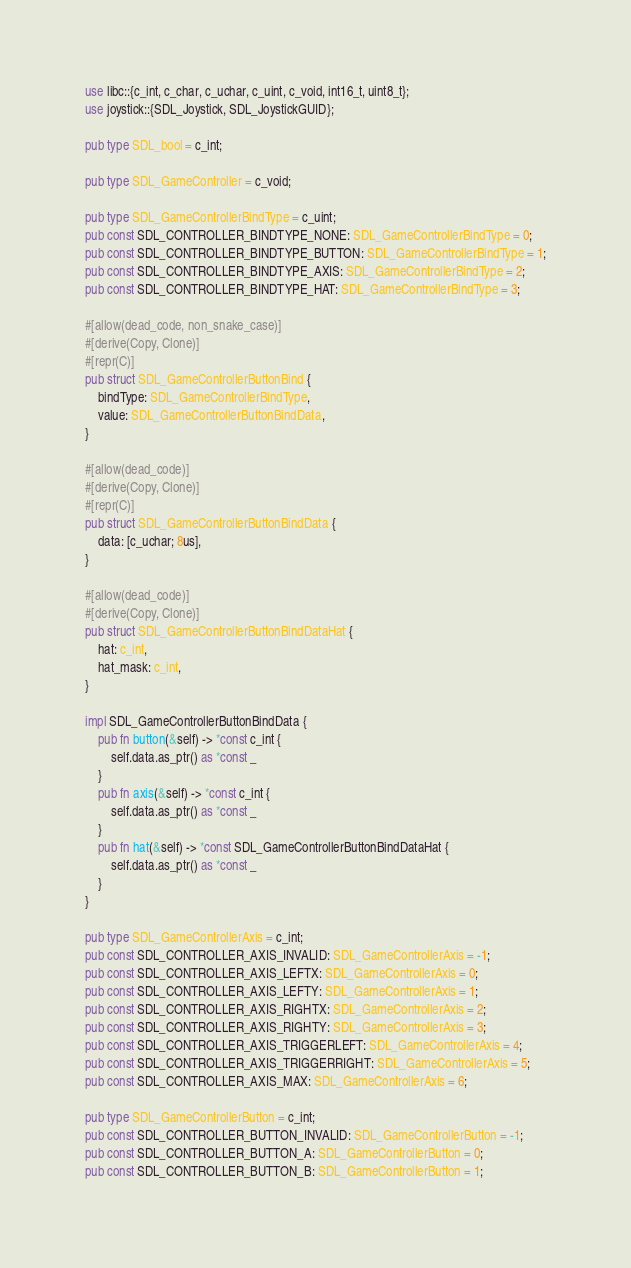Convert code to text. <code><loc_0><loc_0><loc_500><loc_500><_Rust_>use libc::{c_int, c_char, c_uchar, c_uint, c_void, int16_t, uint8_t};
use joystick::{SDL_Joystick, SDL_JoystickGUID};

pub type SDL_bool = c_int;

pub type SDL_GameController = c_void;

pub type SDL_GameControllerBindType = c_uint;
pub const SDL_CONTROLLER_BINDTYPE_NONE: SDL_GameControllerBindType = 0;
pub const SDL_CONTROLLER_BINDTYPE_BUTTON: SDL_GameControllerBindType = 1;
pub const SDL_CONTROLLER_BINDTYPE_AXIS: SDL_GameControllerBindType = 2;
pub const SDL_CONTROLLER_BINDTYPE_HAT: SDL_GameControllerBindType = 3;

#[allow(dead_code, non_snake_case)]
#[derive(Copy, Clone)]
#[repr(C)]
pub struct SDL_GameControllerButtonBind {
    bindType: SDL_GameControllerBindType,
    value: SDL_GameControllerButtonBindData,
}

#[allow(dead_code)]
#[derive(Copy, Clone)]
#[repr(C)]
pub struct SDL_GameControllerButtonBindData {
    data: [c_uchar; 8us],
}

#[allow(dead_code)]
#[derive(Copy, Clone)]
pub struct SDL_GameControllerButtonBindDataHat {
    hat: c_int,
    hat_mask: c_int,
}

impl SDL_GameControllerButtonBindData {
    pub fn button(&self) -> *const c_int {
        self.data.as_ptr() as *const _
    }
    pub fn axis(&self) -> *const c_int {
        self.data.as_ptr() as *const _
    }
    pub fn hat(&self) -> *const SDL_GameControllerButtonBindDataHat {
        self.data.as_ptr() as *const _
    }
}

pub type SDL_GameControllerAxis = c_int;
pub const SDL_CONTROLLER_AXIS_INVALID: SDL_GameControllerAxis = -1;
pub const SDL_CONTROLLER_AXIS_LEFTX: SDL_GameControllerAxis = 0;
pub const SDL_CONTROLLER_AXIS_LEFTY: SDL_GameControllerAxis = 1;
pub const SDL_CONTROLLER_AXIS_RIGHTX: SDL_GameControllerAxis = 2;
pub const SDL_CONTROLLER_AXIS_RIGHTY: SDL_GameControllerAxis = 3;
pub const SDL_CONTROLLER_AXIS_TRIGGERLEFT: SDL_GameControllerAxis = 4;
pub const SDL_CONTROLLER_AXIS_TRIGGERRIGHT: SDL_GameControllerAxis = 5;
pub const SDL_CONTROLLER_AXIS_MAX: SDL_GameControllerAxis = 6;

pub type SDL_GameControllerButton = c_int;
pub const SDL_CONTROLLER_BUTTON_INVALID: SDL_GameControllerButton = -1;
pub const SDL_CONTROLLER_BUTTON_A: SDL_GameControllerButton = 0;
pub const SDL_CONTROLLER_BUTTON_B: SDL_GameControllerButton = 1;</code> 